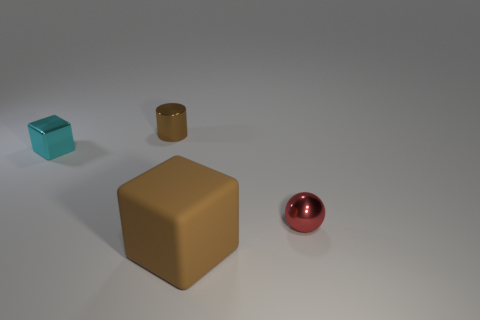Is there anything else that is made of the same material as the large cube?
Provide a succinct answer. No. Do the tiny metal ball and the cylinder have the same color?
Your response must be concise. No. What is the shape of the rubber thing that is the same color as the tiny metal cylinder?
Provide a short and direct response. Cube. Is there a red thing made of the same material as the big brown cube?
Offer a very short reply. No. How many matte objects are either large objects or red objects?
Provide a succinct answer. 1. What shape is the tiny thing on the left side of the brown object that is behind the sphere?
Your response must be concise. Cube. Are there fewer small metal cubes in front of the metal cube than big gray metal cylinders?
Provide a short and direct response. No. What shape is the red thing?
Provide a short and direct response. Sphere. There is a thing on the right side of the rubber object; what size is it?
Your answer should be compact. Small. There is a metal cylinder that is the same size as the metal ball; what color is it?
Provide a short and direct response. Brown. 